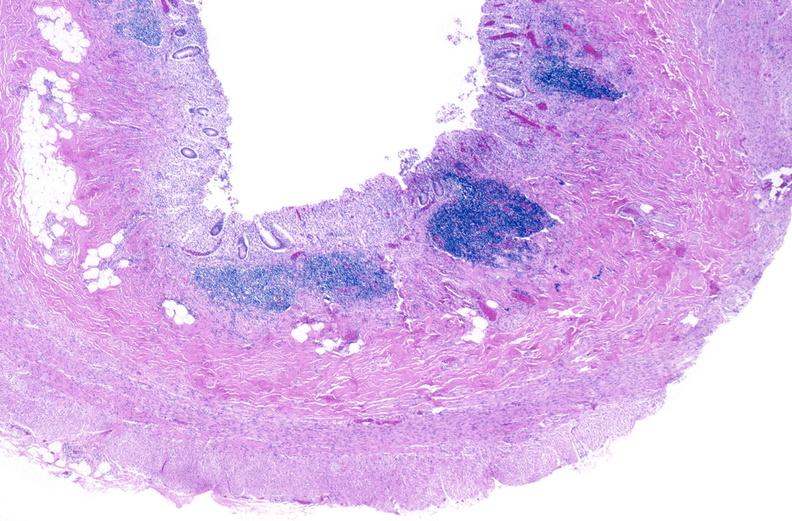s macerated stillborn present?
Answer the question using a single word or phrase. No 